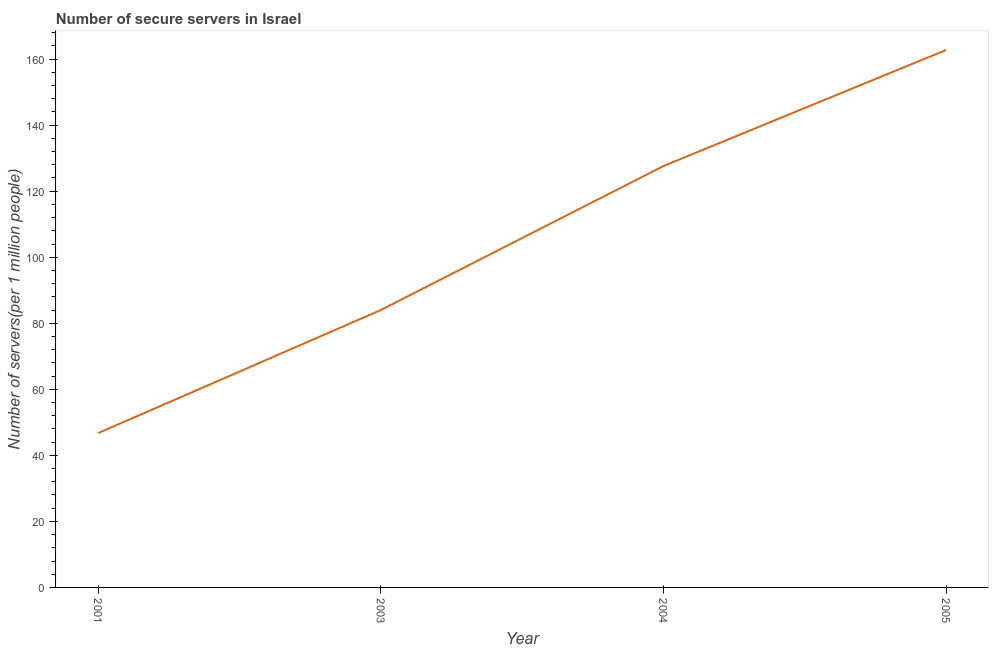What is the number of secure internet servers in 2001?
Your response must be concise. 46.75. Across all years, what is the maximum number of secure internet servers?
Your response must be concise. 162.77. Across all years, what is the minimum number of secure internet servers?
Offer a very short reply. 46.75. In which year was the number of secure internet servers maximum?
Ensure brevity in your answer.  2005. What is the sum of the number of secure internet servers?
Keep it short and to the point. 421.15. What is the difference between the number of secure internet servers in 2001 and 2004?
Your answer should be compact. -80.88. What is the average number of secure internet servers per year?
Provide a succinct answer. 105.29. What is the median number of secure internet servers?
Provide a succinct answer. 105.82. What is the ratio of the number of secure internet servers in 2003 to that in 2004?
Offer a terse response. 0.66. Is the difference between the number of secure internet servers in 2004 and 2005 greater than the difference between any two years?
Your answer should be very brief. No. What is the difference between the highest and the second highest number of secure internet servers?
Your answer should be compact. 35.14. What is the difference between the highest and the lowest number of secure internet servers?
Provide a succinct answer. 116.02. Does the number of secure internet servers monotonically increase over the years?
Offer a very short reply. Yes. How many years are there in the graph?
Give a very brief answer. 4. Are the values on the major ticks of Y-axis written in scientific E-notation?
Make the answer very short. No. Does the graph contain any zero values?
Give a very brief answer. No. What is the title of the graph?
Keep it short and to the point. Number of secure servers in Israel. What is the label or title of the X-axis?
Provide a short and direct response. Year. What is the label or title of the Y-axis?
Ensure brevity in your answer.  Number of servers(per 1 million people). What is the Number of servers(per 1 million people) of 2001?
Give a very brief answer. 46.75. What is the Number of servers(per 1 million people) in 2003?
Your answer should be very brief. 84.01. What is the Number of servers(per 1 million people) in 2004?
Ensure brevity in your answer.  127.63. What is the Number of servers(per 1 million people) in 2005?
Your response must be concise. 162.77. What is the difference between the Number of servers(per 1 million people) in 2001 and 2003?
Provide a short and direct response. -37.26. What is the difference between the Number of servers(per 1 million people) in 2001 and 2004?
Provide a succinct answer. -80.88. What is the difference between the Number of servers(per 1 million people) in 2001 and 2005?
Keep it short and to the point. -116.02. What is the difference between the Number of servers(per 1 million people) in 2003 and 2004?
Offer a terse response. -43.62. What is the difference between the Number of servers(per 1 million people) in 2003 and 2005?
Make the answer very short. -78.76. What is the difference between the Number of servers(per 1 million people) in 2004 and 2005?
Keep it short and to the point. -35.14. What is the ratio of the Number of servers(per 1 million people) in 2001 to that in 2003?
Give a very brief answer. 0.56. What is the ratio of the Number of servers(per 1 million people) in 2001 to that in 2004?
Provide a succinct answer. 0.37. What is the ratio of the Number of servers(per 1 million people) in 2001 to that in 2005?
Make the answer very short. 0.29. What is the ratio of the Number of servers(per 1 million people) in 2003 to that in 2004?
Offer a very short reply. 0.66. What is the ratio of the Number of servers(per 1 million people) in 2003 to that in 2005?
Give a very brief answer. 0.52. What is the ratio of the Number of servers(per 1 million people) in 2004 to that in 2005?
Provide a succinct answer. 0.78. 